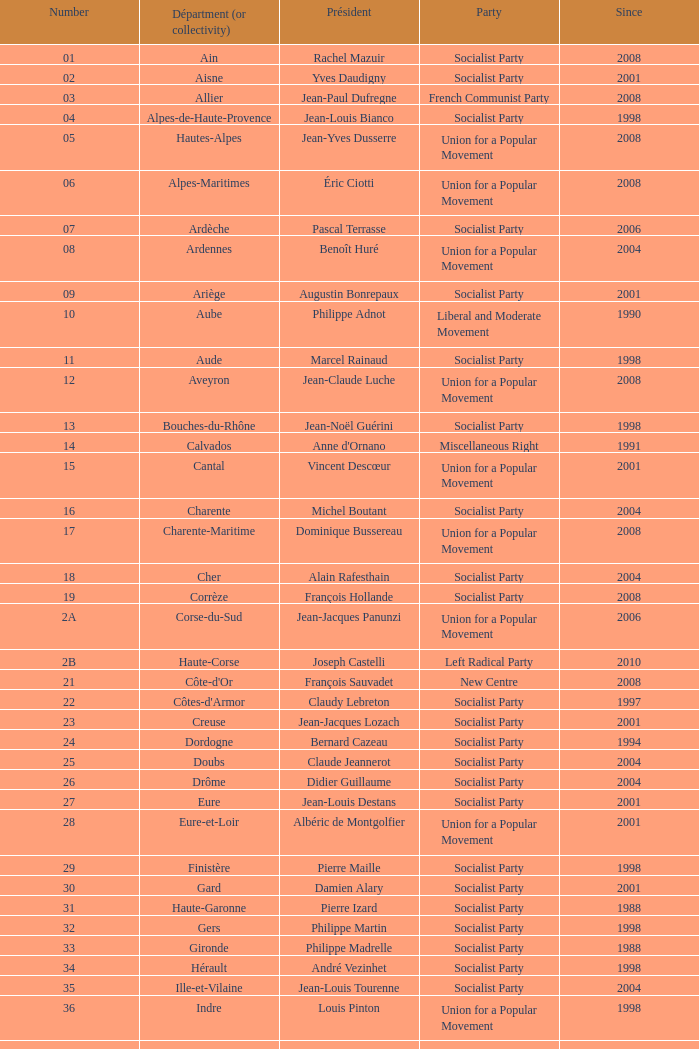Since 2008, which section has guy-dominique kennel as its head? Bas-Rhin. 